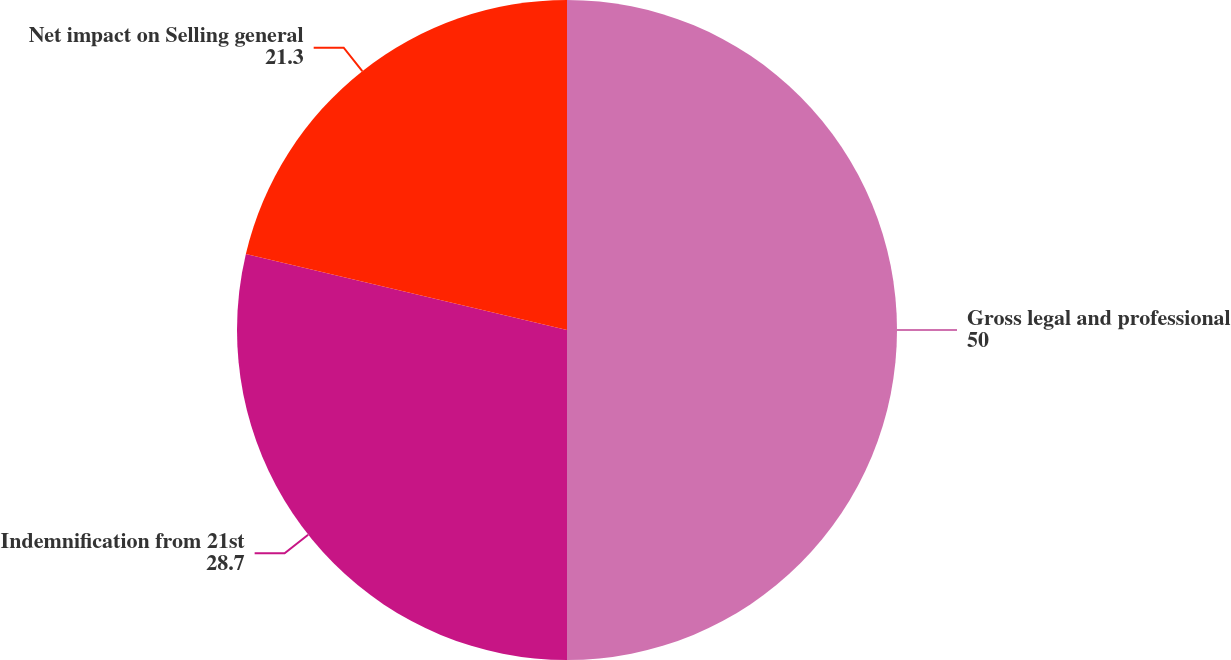<chart> <loc_0><loc_0><loc_500><loc_500><pie_chart><fcel>Gross legal and professional<fcel>Indemnification from 21st<fcel>Net impact on Selling general<nl><fcel>50.0%<fcel>28.7%<fcel>21.3%<nl></chart> 